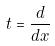Convert formula to latex. <formula><loc_0><loc_0><loc_500><loc_500>t = \frac { d } { d x }</formula> 